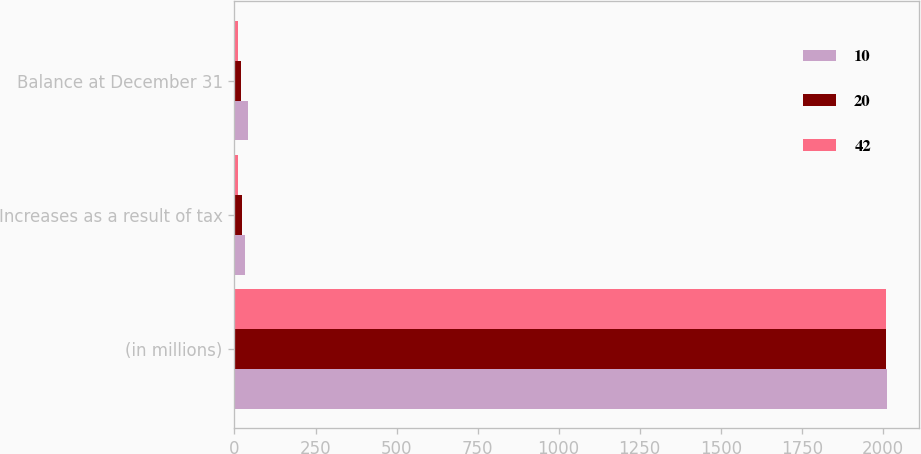<chart> <loc_0><loc_0><loc_500><loc_500><stacked_bar_chart><ecel><fcel>(in millions)<fcel>Increases as a result of tax<fcel>Balance at December 31<nl><fcel>10<fcel>2012<fcel>33<fcel>42<nl><fcel>20<fcel>2011<fcel>22<fcel>20<nl><fcel>42<fcel>2010<fcel>10<fcel>10<nl></chart> 